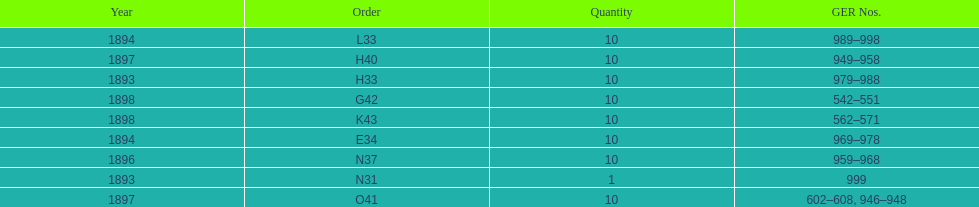What is the last year listed? 1898. 